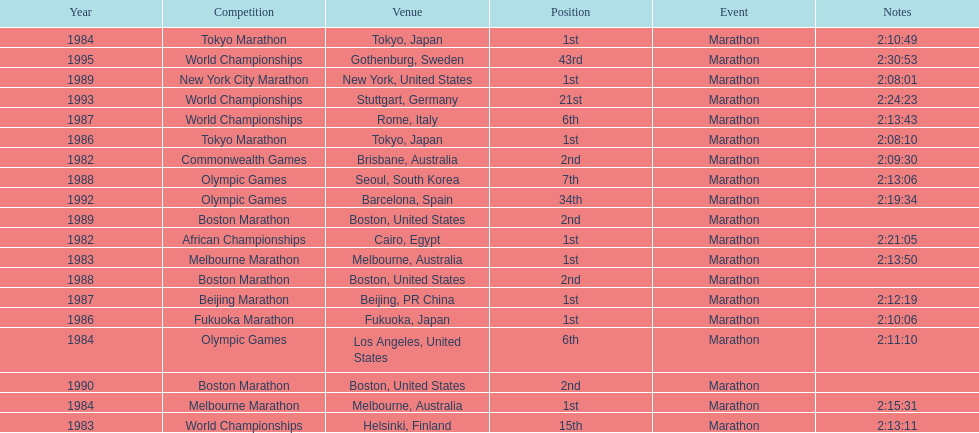In what year did the runner participate in the most marathons? 1984. Parse the full table. {'header': ['Year', 'Competition', 'Venue', 'Position', 'Event', 'Notes'], 'rows': [['1984', 'Tokyo Marathon', 'Tokyo, Japan', '1st', 'Marathon', '2:10:49'], ['1995', 'World Championships', 'Gothenburg, Sweden', '43rd', 'Marathon', '2:30:53'], ['1989', 'New York City Marathon', 'New York, United States', '1st', 'Marathon', '2:08:01'], ['1993', 'World Championships', 'Stuttgart, Germany', '21st', 'Marathon', '2:24:23'], ['1987', 'World Championships', 'Rome, Italy', '6th', 'Marathon', '2:13:43'], ['1986', 'Tokyo Marathon', 'Tokyo, Japan', '1st', 'Marathon', '2:08:10'], ['1982', 'Commonwealth Games', 'Brisbane, Australia', '2nd', 'Marathon', '2:09:30'], ['1988', 'Olympic Games', 'Seoul, South Korea', '7th', 'Marathon', '2:13:06'], ['1992', 'Olympic Games', 'Barcelona, Spain', '34th', 'Marathon', '2:19:34'], ['1989', 'Boston Marathon', 'Boston, United States', '2nd', 'Marathon', ''], ['1982', 'African Championships', 'Cairo, Egypt', '1st', 'Marathon', '2:21:05'], ['1983', 'Melbourne Marathon', 'Melbourne, Australia', '1st', 'Marathon', '2:13:50'], ['1988', 'Boston Marathon', 'Boston, United States', '2nd', 'Marathon', ''], ['1987', 'Beijing Marathon', 'Beijing, PR China', '1st', 'Marathon', '2:12:19'], ['1986', 'Fukuoka Marathon', 'Fukuoka, Japan', '1st', 'Marathon', '2:10:06'], ['1984', 'Olympic Games', 'Los Angeles, United States', '6th', 'Marathon', '2:11:10'], ['1990', 'Boston Marathon', 'Boston, United States', '2nd', 'Marathon', ''], ['1984', 'Melbourne Marathon', 'Melbourne, Australia', '1st', 'Marathon', '2:15:31'], ['1983', 'World Championships', 'Helsinki, Finland', '15th', 'Marathon', '2:13:11']]} 